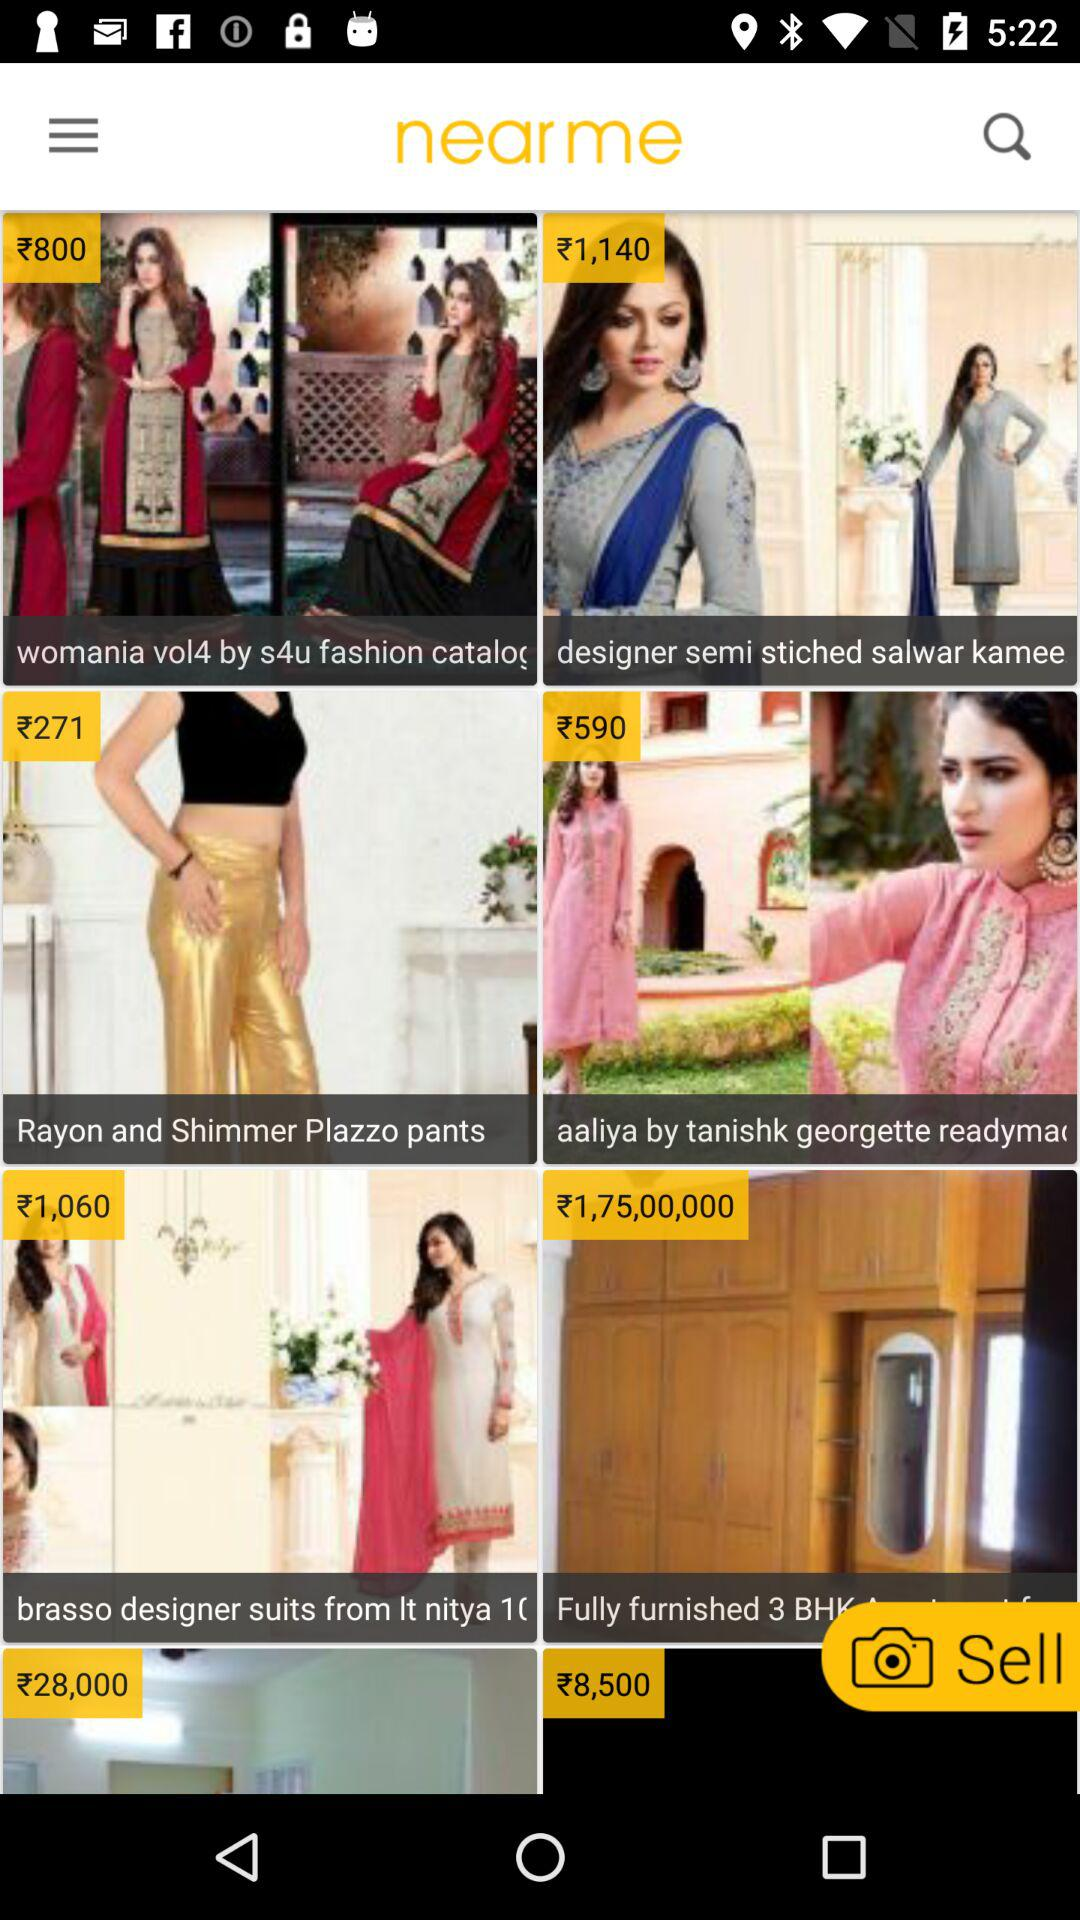Which dress cost ₹1,060? The dress is "brasso designer suits". 